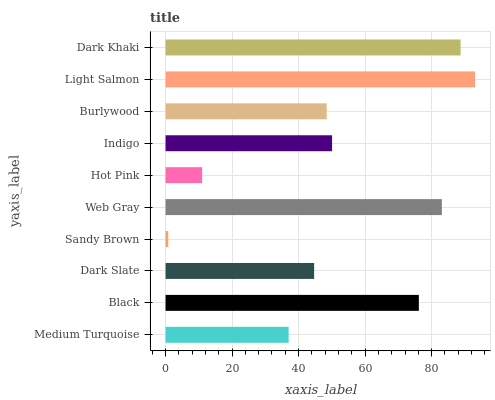Is Sandy Brown the minimum?
Answer yes or no. Yes. Is Light Salmon the maximum?
Answer yes or no. Yes. Is Black the minimum?
Answer yes or no. No. Is Black the maximum?
Answer yes or no. No. Is Black greater than Medium Turquoise?
Answer yes or no. Yes. Is Medium Turquoise less than Black?
Answer yes or no. Yes. Is Medium Turquoise greater than Black?
Answer yes or no. No. Is Black less than Medium Turquoise?
Answer yes or no. No. Is Indigo the high median?
Answer yes or no. Yes. Is Burlywood the low median?
Answer yes or no. Yes. Is Hot Pink the high median?
Answer yes or no. No. Is Hot Pink the low median?
Answer yes or no. No. 